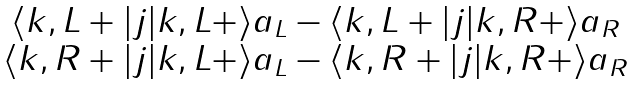<formula> <loc_0><loc_0><loc_500><loc_500>\begin{matrix} \langle k , L + | j | k , L + \rangle a _ { L } - \langle k , L + | j | k , R + \rangle a _ { R } \\ \langle k , R + | j | k , L + \rangle a _ { L } - \langle k , R + | j | k , R + \rangle a _ { R } \end{matrix}</formula> 